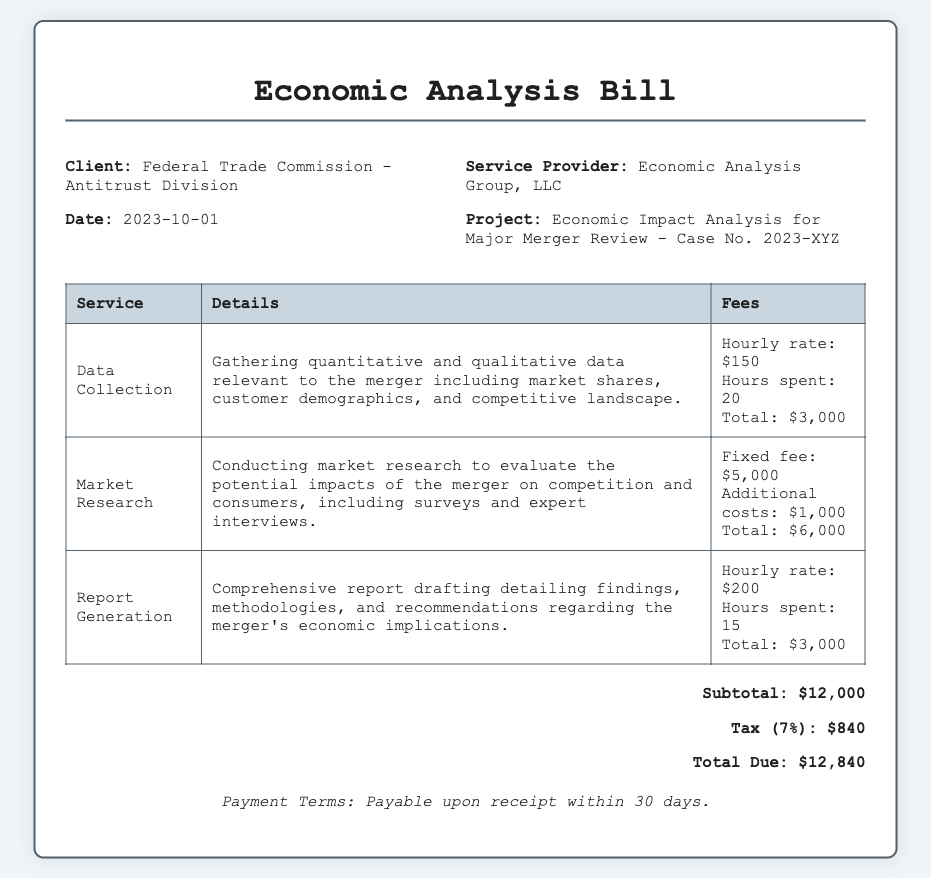What is the date of the bill? The date of the bill is stated at the top of the document as 2023-10-01.
Answer: 2023-10-01 Who is the service provider? The service provider is mentioned in the header of the document as Economic Analysis Group, LLC.
Answer: Economic Analysis Group, LLC What is the total due amount? The total due amount is presented in the document under the total section, calculated as $12,840.
Answer: $12,840 How many hours were spent on data collection? The total hours spent on data collection is listed in the service details as 20 hours.
Answer: 20 What is the subtotal before tax? The subtotal is explicitly mentioned in the total section of the document, which is $12,000.
Answer: $12,000 What is the tax rate mentioned in the bill? The tax rate is specified in the document as 7%.
Answer: 7% What is the total fee for market research? The total fee for market research is detailed as $6,000 in the fees section.
Answer: $6,000 What service has the highest hourly rate? The report generation service has the highest hourly rate listed as $200 per hour.
Answer: Report Generation What is the payment term specified? The payment term is clearly articulated at the bottom of the document and states payable upon receipt within 30 days.
Answer: Payable upon receipt within 30 days 